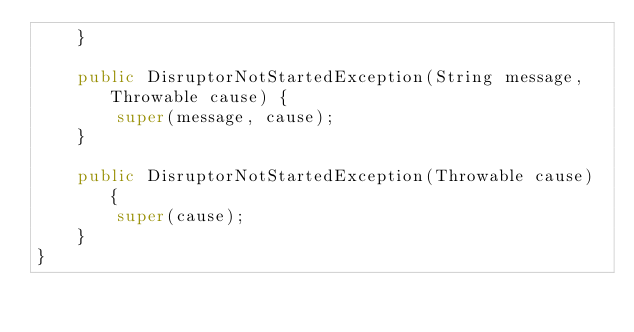<code> <loc_0><loc_0><loc_500><loc_500><_Java_>    }

    public DisruptorNotStartedException(String message, Throwable cause) {
        super(message, cause);
    }

    public DisruptorNotStartedException(Throwable cause) {
        super(cause);
    }
}
</code> 